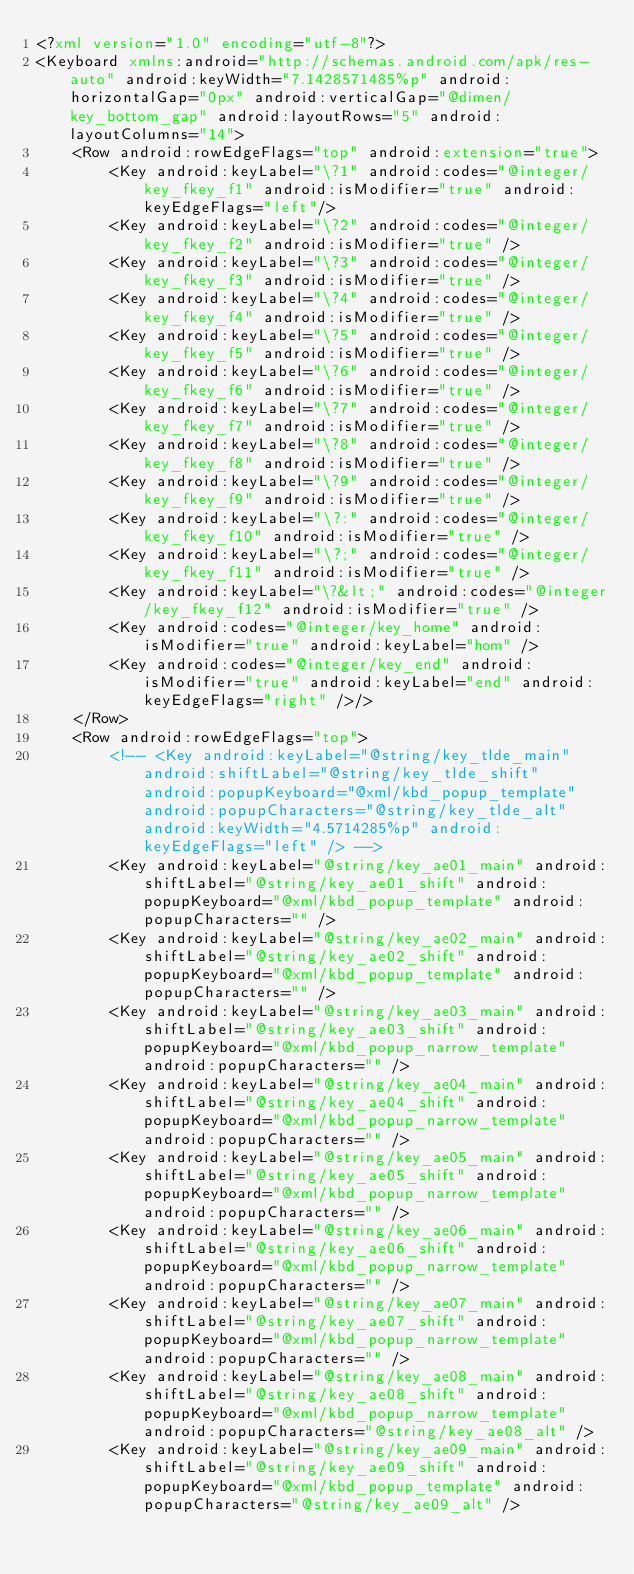<code> <loc_0><loc_0><loc_500><loc_500><_XML_><?xml version="1.0" encoding="utf-8"?>
<Keyboard xmlns:android="http://schemas.android.com/apk/res-auto" android:keyWidth="7.1428571485%p" android:horizontalGap="0px" android:verticalGap="@dimen/key_bottom_gap" android:layoutRows="5" android:layoutColumns="14">
    <Row android:rowEdgeFlags="top" android:extension="true">
        <Key android:keyLabel="\?1" android:codes="@integer/key_fkey_f1" android:isModifier="true" android:keyEdgeFlags="left"/>
        <Key android:keyLabel="\?2" android:codes="@integer/key_fkey_f2" android:isModifier="true" />
        <Key android:keyLabel="\?3" android:codes="@integer/key_fkey_f3" android:isModifier="true" />
        <Key android:keyLabel="\?4" android:codes="@integer/key_fkey_f4" android:isModifier="true" />
        <Key android:keyLabel="\?5" android:codes="@integer/key_fkey_f5" android:isModifier="true" />
        <Key android:keyLabel="\?6" android:codes="@integer/key_fkey_f6" android:isModifier="true" />
        <Key android:keyLabel="\?7" android:codes="@integer/key_fkey_f7" android:isModifier="true" />
        <Key android:keyLabel="\?8" android:codes="@integer/key_fkey_f8" android:isModifier="true" />
        <Key android:keyLabel="\?9" android:codes="@integer/key_fkey_f9" android:isModifier="true" />
        <Key android:keyLabel="\?:" android:codes="@integer/key_fkey_f10" android:isModifier="true" />
        <Key android:keyLabel="\?;" android:codes="@integer/key_fkey_f11" android:isModifier="true" />
        <Key android:keyLabel="\?&lt;" android:codes="@integer/key_fkey_f12" android:isModifier="true" />
	    <Key android:codes="@integer/key_home" android:isModifier="true" android:keyLabel="hom" />
	    <Key android:codes="@integer/key_end" android:isModifier="true" android:keyLabel="end" android:keyEdgeFlags="right" />/>
    </Row>
    <Row android:rowEdgeFlags="top">
        <!-- <Key android:keyLabel="@string/key_tlde_main" android:shiftLabel="@string/key_tlde_shift" android:popupKeyboard="@xml/kbd_popup_template" android:popupCharacters="@string/key_tlde_alt" android:keyWidth="4.5714285%p" android:keyEdgeFlags="left" /> -->
        <Key android:keyLabel="@string/key_ae01_main" android:shiftLabel="@string/key_ae01_shift" android:popupKeyboard="@xml/kbd_popup_template" android:popupCharacters="" />
        <Key android:keyLabel="@string/key_ae02_main" android:shiftLabel="@string/key_ae02_shift" android:popupKeyboard="@xml/kbd_popup_template" android:popupCharacters="" />
        <Key android:keyLabel="@string/key_ae03_main" android:shiftLabel="@string/key_ae03_shift" android:popupKeyboard="@xml/kbd_popup_narrow_template" android:popupCharacters="" />
        <Key android:keyLabel="@string/key_ae04_main" android:shiftLabel="@string/key_ae04_shift" android:popupKeyboard="@xml/kbd_popup_narrow_template" android:popupCharacters="" />
        <Key android:keyLabel="@string/key_ae05_main" android:shiftLabel="@string/key_ae05_shift" android:popupKeyboard="@xml/kbd_popup_narrow_template" android:popupCharacters="" />
        <Key android:keyLabel="@string/key_ae06_main" android:shiftLabel="@string/key_ae06_shift" android:popupKeyboard="@xml/kbd_popup_narrow_template" android:popupCharacters="" />
        <Key android:keyLabel="@string/key_ae07_main" android:shiftLabel="@string/key_ae07_shift" android:popupKeyboard="@xml/kbd_popup_narrow_template" android:popupCharacters="" />
        <Key android:keyLabel="@string/key_ae08_main" android:shiftLabel="@string/key_ae08_shift" android:popupKeyboard="@xml/kbd_popup_narrow_template" android:popupCharacters="@string/key_ae08_alt" />
        <Key android:keyLabel="@string/key_ae09_main" android:shiftLabel="@string/key_ae09_shift" android:popupKeyboard="@xml/kbd_popup_template" android:popupCharacters="@string/key_ae09_alt" /></code> 